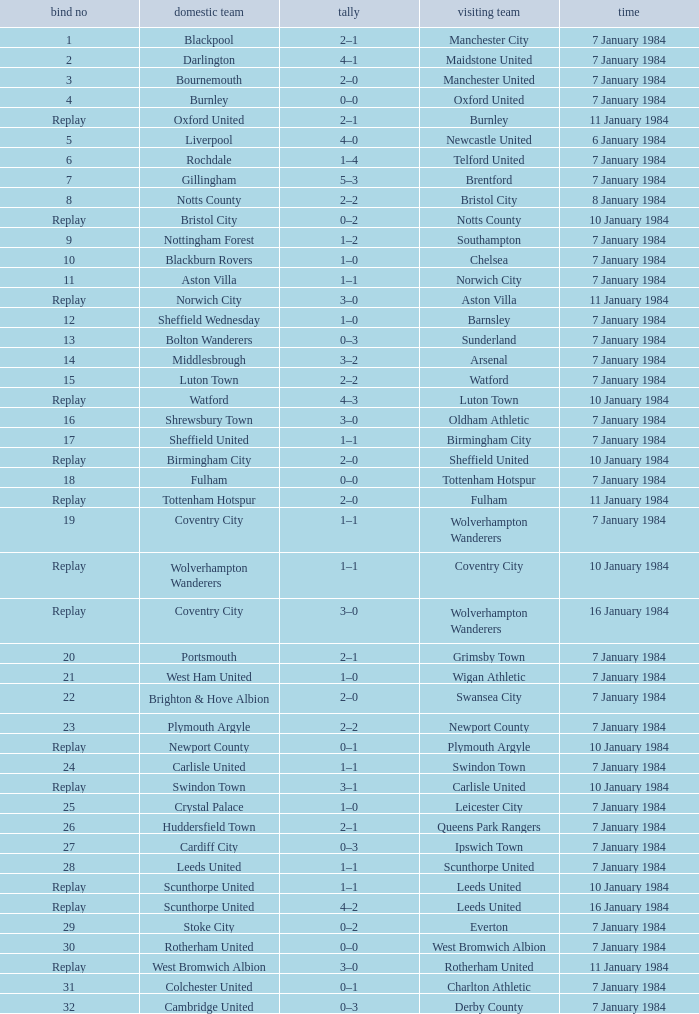Who was the away team against the home team Sheffield United? Birmingham City. Write the full table. {'header': ['bind no', 'domestic team', 'tally', 'visiting team', 'time'], 'rows': [['1', 'Blackpool', '2–1', 'Manchester City', '7 January 1984'], ['2', 'Darlington', '4–1', 'Maidstone United', '7 January 1984'], ['3', 'Bournemouth', '2–0', 'Manchester United', '7 January 1984'], ['4', 'Burnley', '0–0', 'Oxford United', '7 January 1984'], ['Replay', 'Oxford United', '2–1', 'Burnley', '11 January 1984'], ['5', 'Liverpool', '4–0', 'Newcastle United', '6 January 1984'], ['6', 'Rochdale', '1–4', 'Telford United', '7 January 1984'], ['7', 'Gillingham', '5–3', 'Brentford', '7 January 1984'], ['8', 'Notts County', '2–2', 'Bristol City', '8 January 1984'], ['Replay', 'Bristol City', '0–2', 'Notts County', '10 January 1984'], ['9', 'Nottingham Forest', '1–2', 'Southampton', '7 January 1984'], ['10', 'Blackburn Rovers', '1–0', 'Chelsea', '7 January 1984'], ['11', 'Aston Villa', '1–1', 'Norwich City', '7 January 1984'], ['Replay', 'Norwich City', '3–0', 'Aston Villa', '11 January 1984'], ['12', 'Sheffield Wednesday', '1–0', 'Barnsley', '7 January 1984'], ['13', 'Bolton Wanderers', '0–3', 'Sunderland', '7 January 1984'], ['14', 'Middlesbrough', '3–2', 'Arsenal', '7 January 1984'], ['15', 'Luton Town', '2–2', 'Watford', '7 January 1984'], ['Replay', 'Watford', '4–3', 'Luton Town', '10 January 1984'], ['16', 'Shrewsbury Town', '3–0', 'Oldham Athletic', '7 January 1984'], ['17', 'Sheffield United', '1–1', 'Birmingham City', '7 January 1984'], ['Replay', 'Birmingham City', '2–0', 'Sheffield United', '10 January 1984'], ['18', 'Fulham', '0–0', 'Tottenham Hotspur', '7 January 1984'], ['Replay', 'Tottenham Hotspur', '2–0', 'Fulham', '11 January 1984'], ['19', 'Coventry City', '1–1', 'Wolverhampton Wanderers', '7 January 1984'], ['Replay', 'Wolverhampton Wanderers', '1–1', 'Coventry City', '10 January 1984'], ['Replay', 'Coventry City', '3–0', 'Wolverhampton Wanderers', '16 January 1984'], ['20', 'Portsmouth', '2–1', 'Grimsby Town', '7 January 1984'], ['21', 'West Ham United', '1–0', 'Wigan Athletic', '7 January 1984'], ['22', 'Brighton & Hove Albion', '2–0', 'Swansea City', '7 January 1984'], ['23', 'Plymouth Argyle', '2–2', 'Newport County', '7 January 1984'], ['Replay', 'Newport County', '0–1', 'Plymouth Argyle', '10 January 1984'], ['24', 'Carlisle United', '1–1', 'Swindon Town', '7 January 1984'], ['Replay', 'Swindon Town', '3–1', 'Carlisle United', '10 January 1984'], ['25', 'Crystal Palace', '1–0', 'Leicester City', '7 January 1984'], ['26', 'Huddersfield Town', '2–1', 'Queens Park Rangers', '7 January 1984'], ['27', 'Cardiff City', '0–3', 'Ipswich Town', '7 January 1984'], ['28', 'Leeds United', '1–1', 'Scunthorpe United', '7 January 1984'], ['Replay', 'Scunthorpe United', '1–1', 'Leeds United', '10 January 1984'], ['Replay', 'Scunthorpe United', '4–2', 'Leeds United', '16 January 1984'], ['29', 'Stoke City', '0–2', 'Everton', '7 January 1984'], ['30', 'Rotherham United', '0–0', 'West Bromwich Albion', '7 January 1984'], ['Replay', 'West Bromwich Albion', '3–0', 'Rotherham United', '11 January 1984'], ['31', 'Colchester United', '0–1', 'Charlton Athletic', '7 January 1984'], ['32', 'Cambridge United', '0–3', 'Derby County', '7 January 1984']]} 